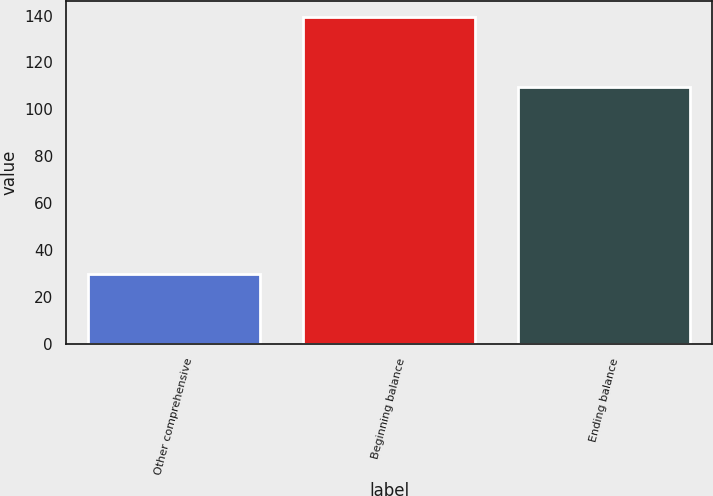Convert chart to OTSL. <chart><loc_0><loc_0><loc_500><loc_500><bar_chart><fcel>Other comprehensive<fcel>Beginning balance<fcel>Ending balance<nl><fcel>29.5<fcel>139.2<fcel>109.7<nl></chart> 